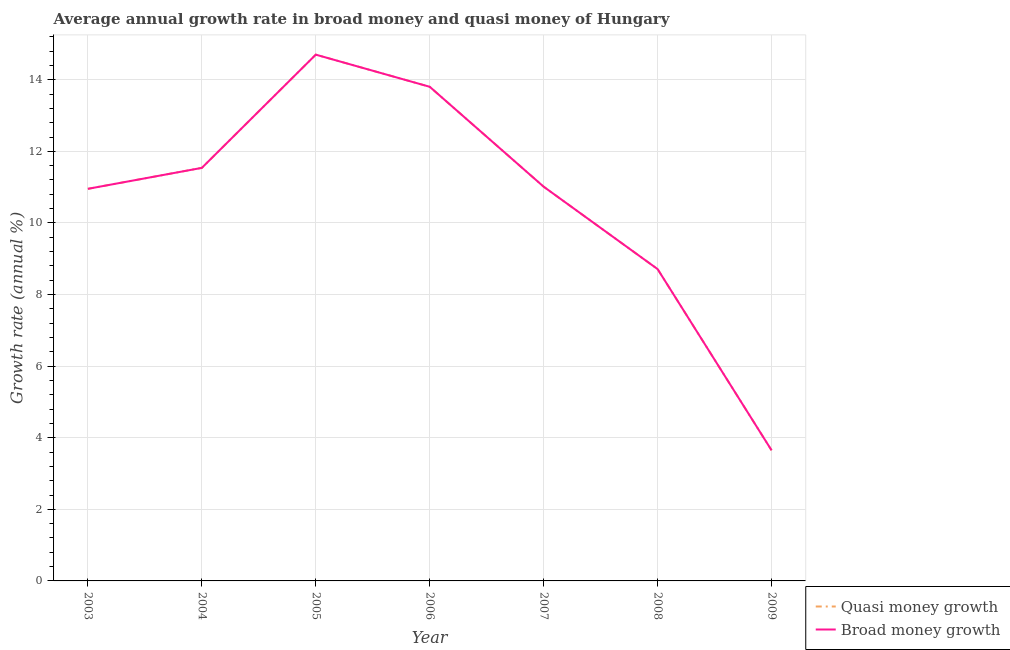Is the number of lines equal to the number of legend labels?
Ensure brevity in your answer.  Yes. What is the annual growth rate in broad money in 2003?
Provide a succinct answer. 10.95. Across all years, what is the maximum annual growth rate in quasi money?
Offer a terse response. 14.7. Across all years, what is the minimum annual growth rate in quasi money?
Your response must be concise. 3.65. In which year was the annual growth rate in quasi money minimum?
Your response must be concise. 2009. What is the total annual growth rate in broad money in the graph?
Your answer should be compact. 74.36. What is the difference between the annual growth rate in broad money in 2006 and that in 2008?
Offer a terse response. 5.09. What is the difference between the annual growth rate in quasi money in 2003 and the annual growth rate in broad money in 2008?
Your answer should be compact. 2.24. What is the average annual growth rate in broad money per year?
Keep it short and to the point. 10.62. What is the ratio of the annual growth rate in quasi money in 2003 to that in 2007?
Provide a short and direct response. 0.99. What is the difference between the highest and the second highest annual growth rate in broad money?
Provide a short and direct response. 0.9. What is the difference between the highest and the lowest annual growth rate in broad money?
Your answer should be very brief. 11.05. In how many years, is the annual growth rate in quasi money greater than the average annual growth rate in quasi money taken over all years?
Give a very brief answer. 5. Is the sum of the annual growth rate in quasi money in 2003 and 2007 greater than the maximum annual growth rate in broad money across all years?
Ensure brevity in your answer.  Yes. Does the annual growth rate in broad money monotonically increase over the years?
Provide a succinct answer. No. Is the annual growth rate in quasi money strictly less than the annual growth rate in broad money over the years?
Make the answer very short. No. How many lines are there?
Your answer should be very brief. 2. Are the values on the major ticks of Y-axis written in scientific E-notation?
Make the answer very short. No. How many legend labels are there?
Ensure brevity in your answer.  2. What is the title of the graph?
Give a very brief answer. Average annual growth rate in broad money and quasi money of Hungary. What is the label or title of the Y-axis?
Give a very brief answer. Growth rate (annual %). What is the Growth rate (annual %) of Quasi money growth in 2003?
Give a very brief answer. 10.95. What is the Growth rate (annual %) in Broad money growth in 2003?
Your answer should be compact. 10.95. What is the Growth rate (annual %) of Quasi money growth in 2004?
Your response must be concise. 11.54. What is the Growth rate (annual %) of Broad money growth in 2004?
Offer a terse response. 11.54. What is the Growth rate (annual %) in Quasi money growth in 2005?
Make the answer very short. 14.7. What is the Growth rate (annual %) of Broad money growth in 2005?
Give a very brief answer. 14.7. What is the Growth rate (annual %) in Quasi money growth in 2006?
Your answer should be compact. 13.8. What is the Growth rate (annual %) of Broad money growth in 2006?
Make the answer very short. 13.8. What is the Growth rate (annual %) in Quasi money growth in 2007?
Your answer should be compact. 11.01. What is the Growth rate (annual %) in Broad money growth in 2007?
Your answer should be very brief. 11.01. What is the Growth rate (annual %) in Quasi money growth in 2008?
Give a very brief answer. 8.71. What is the Growth rate (annual %) in Broad money growth in 2008?
Give a very brief answer. 8.71. What is the Growth rate (annual %) of Quasi money growth in 2009?
Offer a very short reply. 3.65. What is the Growth rate (annual %) of Broad money growth in 2009?
Make the answer very short. 3.65. Across all years, what is the maximum Growth rate (annual %) in Quasi money growth?
Keep it short and to the point. 14.7. Across all years, what is the maximum Growth rate (annual %) in Broad money growth?
Make the answer very short. 14.7. Across all years, what is the minimum Growth rate (annual %) in Quasi money growth?
Offer a very short reply. 3.65. Across all years, what is the minimum Growth rate (annual %) in Broad money growth?
Make the answer very short. 3.65. What is the total Growth rate (annual %) in Quasi money growth in the graph?
Give a very brief answer. 74.36. What is the total Growth rate (annual %) in Broad money growth in the graph?
Your answer should be compact. 74.36. What is the difference between the Growth rate (annual %) in Quasi money growth in 2003 and that in 2004?
Your answer should be compact. -0.59. What is the difference between the Growth rate (annual %) of Broad money growth in 2003 and that in 2004?
Your response must be concise. -0.59. What is the difference between the Growth rate (annual %) of Quasi money growth in 2003 and that in 2005?
Provide a succinct answer. -3.75. What is the difference between the Growth rate (annual %) in Broad money growth in 2003 and that in 2005?
Your answer should be very brief. -3.75. What is the difference between the Growth rate (annual %) of Quasi money growth in 2003 and that in 2006?
Make the answer very short. -2.85. What is the difference between the Growth rate (annual %) in Broad money growth in 2003 and that in 2006?
Provide a succinct answer. -2.85. What is the difference between the Growth rate (annual %) in Quasi money growth in 2003 and that in 2007?
Your answer should be compact. -0.06. What is the difference between the Growth rate (annual %) in Broad money growth in 2003 and that in 2007?
Keep it short and to the point. -0.06. What is the difference between the Growth rate (annual %) in Quasi money growth in 2003 and that in 2008?
Provide a short and direct response. 2.24. What is the difference between the Growth rate (annual %) of Broad money growth in 2003 and that in 2008?
Offer a very short reply. 2.24. What is the difference between the Growth rate (annual %) of Quasi money growth in 2003 and that in 2009?
Give a very brief answer. 7.3. What is the difference between the Growth rate (annual %) of Broad money growth in 2003 and that in 2009?
Provide a succinct answer. 7.3. What is the difference between the Growth rate (annual %) of Quasi money growth in 2004 and that in 2005?
Your answer should be compact. -3.16. What is the difference between the Growth rate (annual %) of Broad money growth in 2004 and that in 2005?
Offer a terse response. -3.16. What is the difference between the Growth rate (annual %) of Quasi money growth in 2004 and that in 2006?
Your response must be concise. -2.27. What is the difference between the Growth rate (annual %) of Broad money growth in 2004 and that in 2006?
Provide a succinct answer. -2.27. What is the difference between the Growth rate (annual %) in Quasi money growth in 2004 and that in 2007?
Provide a succinct answer. 0.53. What is the difference between the Growth rate (annual %) in Broad money growth in 2004 and that in 2007?
Keep it short and to the point. 0.53. What is the difference between the Growth rate (annual %) of Quasi money growth in 2004 and that in 2008?
Your response must be concise. 2.83. What is the difference between the Growth rate (annual %) of Broad money growth in 2004 and that in 2008?
Provide a succinct answer. 2.83. What is the difference between the Growth rate (annual %) of Quasi money growth in 2004 and that in 2009?
Your response must be concise. 7.89. What is the difference between the Growth rate (annual %) of Broad money growth in 2004 and that in 2009?
Keep it short and to the point. 7.89. What is the difference between the Growth rate (annual %) of Quasi money growth in 2005 and that in 2006?
Give a very brief answer. 0.9. What is the difference between the Growth rate (annual %) of Broad money growth in 2005 and that in 2006?
Give a very brief answer. 0.9. What is the difference between the Growth rate (annual %) of Quasi money growth in 2005 and that in 2007?
Offer a terse response. 3.69. What is the difference between the Growth rate (annual %) of Broad money growth in 2005 and that in 2007?
Offer a very short reply. 3.69. What is the difference between the Growth rate (annual %) in Quasi money growth in 2005 and that in 2008?
Keep it short and to the point. 5.99. What is the difference between the Growth rate (annual %) of Broad money growth in 2005 and that in 2008?
Provide a short and direct response. 5.99. What is the difference between the Growth rate (annual %) in Quasi money growth in 2005 and that in 2009?
Ensure brevity in your answer.  11.05. What is the difference between the Growth rate (annual %) in Broad money growth in 2005 and that in 2009?
Provide a short and direct response. 11.05. What is the difference between the Growth rate (annual %) of Quasi money growth in 2006 and that in 2007?
Provide a short and direct response. 2.79. What is the difference between the Growth rate (annual %) of Broad money growth in 2006 and that in 2007?
Your answer should be very brief. 2.79. What is the difference between the Growth rate (annual %) in Quasi money growth in 2006 and that in 2008?
Give a very brief answer. 5.09. What is the difference between the Growth rate (annual %) of Broad money growth in 2006 and that in 2008?
Your response must be concise. 5.09. What is the difference between the Growth rate (annual %) in Quasi money growth in 2006 and that in 2009?
Ensure brevity in your answer.  10.15. What is the difference between the Growth rate (annual %) of Broad money growth in 2006 and that in 2009?
Ensure brevity in your answer.  10.15. What is the difference between the Growth rate (annual %) in Quasi money growth in 2007 and that in 2008?
Offer a very short reply. 2.3. What is the difference between the Growth rate (annual %) in Broad money growth in 2007 and that in 2008?
Keep it short and to the point. 2.3. What is the difference between the Growth rate (annual %) in Quasi money growth in 2007 and that in 2009?
Your answer should be very brief. 7.36. What is the difference between the Growth rate (annual %) of Broad money growth in 2007 and that in 2009?
Your response must be concise. 7.36. What is the difference between the Growth rate (annual %) of Quasi money growth in 2008 and that in 2009?
Your answer should be very brief. 5.06. What is the difference between the Growth rate (annual %) of Broad money growth in 2008 and that in 2009?
Your answer should be compact. 5.06. What is the difference between the Growth rate (annual %) of Quasi money growth in 2003 and the Growth rate (annual %) of Broad money growth in 2004?
Your answer should be very brief. -0.59. What is the difference between the Growth rate (annual %) in Quasi money growth in 2003 and the Growth rate (annual %) in Broad money growth in 2005?
Offer a very short reply. -3.75. What is the difference between the Growth rate (annual %) of Quasi money growth in 2003 and the Growth rate (annual %) of Broad money growth in 2006?
Your answer should be very brief. -2.85. What is the difference between the Growth rate (annual %) of Quasi money growth in 2003 and the Growth rate (annual %) of Broad money growth in 2007?
Offer a terse response. -0.06. What is the difference between the Growth rate (annual %) of Quasi money growth in 2003 and the Growth rate (annual %) of Broad money growth in 2008?
Ensure brevity in your answer.  2.24. What is the difference between the Growth rate (annual %) in Quasi money growth in 2003 and the Growth rate (annual %) in Broad money growth in 2009?
Offer a terse response. 7.3. What is the difference between the Growth rate (annual %) of Quasi money growth in 2004 and the Growth rate (annual %) of Broad money growth in 2005?
Provide a short and direct response. -3.16. What is the difference between the Growth rate (annual %) of Quasi money growth in 2004 and the Growth rate (annual %) of Broad money growth in 2006?
Keep it short and to the point. -2.27. What is the difference between the Growth rate (annual %) of Quasi money growth in 2004 and the Growth rate (annual %) of Broad money growth in 2007?
Make the answer very short. 0.53. What is the difference between the Growth rate (annual %) of Quasi money growth in 2004 and the Growth rate (annual %) of Broad money growth in 2008?
Your answer should be compact. 2.83. What is the difference between the Growth rate (annual %) of Quasi money growth in 2004 and the Growth rate (annual %) of Broad money growth in 2009?
Provide a short and direct response. 7.89. What is the difference between the Growth rate (annual %) in Quasi money growth in 2005 and the Growth rate (annual %) in Broad money growth in 2006?
Ensure brevity in your answer.  0.9. What is the difference between the Growth rate (annual %) of Quasi money growth in 2005 and the Growth rate (annual %) of Broad money growth in 2007?
Keep it short and to the point. 3.69. What is the difference between the Growth rate (annual %) in Quasi money growth in 2005 and the Growth rate (annual %) in Broad money growth in 2008?
Offer a terse response. 5.99. What is the difference between the Growth rate (annual %) of Quasi money growth in 2005 and the Growth rate (annual %) of Broad money growth in 2009?
Your response must be concise. 11.05. What is the difference between the Growth rate (annual %) of Quasi money growth in 2006 and the Growth rate (annual %) of Broad money growth in 2007?
Ensure brevity in your answer.  2.79. What is the difference between the Growth rate (annual %) of Quasi money growth in 2006 and the Growth rate (annual %) of Broad money growth in 2008?
Ensure brevity in your answer.  5.09. What is the difference between the Growth rate (annual %) of Quasi money growth in 2006 and the Growth rate (annual %) of Broad money growth in 2009?
Give a very brief answer. 10.15. What is the difference between the Growth rate (annual %) of Quasi money growth in 2007 and the Growth rate (annual %) of Broad money growth in 2008?
Give a very brief answer. 2.3. What is the difference between the Growth rate (annual %) in Quasi money growth in 2007 and the Growth rate (annual %) in Broad money growth in 2009?
Provide a succinct answer. 7.36. What is the difference between the Growth rate (annual %) in Quasi money growth in 2008 and the Growth rate (annual %) in Broad money growth in 2009?
Keep it short and to the point. 5.06. What is the average Growth rate (annual %) of Quasi money growth per year?
Provide a succinct answer. 10.62. What is the average Growth rate (annual %) of Broad money growth per year?
Give a very brief answer. 10.62. In the year 2003, what is the difference between the Growth rate (annual %) in Quasi money growth and Growth rate (annual %) in Broad money growth?
Keep it short and to the point. 0. In the year 2004, what is the difference between the Growth rate (annual %) of Quasi money growth and Growth rate (annual %) of Broad money growth?
Give a very brief answer. 0. In the year 2008, what is the difference between the Growth rate (annual %) of Quasi money growth and Growth rate (annual %) of Broad money growth?
Provide a short and direct response. 0. What is the ratio of the Growth rate (annual %) in Quasi money growth in 2003 to that in 2004?
Your answer should be compact. 0.95. What is the ratio of the Growth rate (annual %) of Broad money growth in 2003 to that in 2004?
Your response must be concise. 0.95. What is the ratio of the Growth rate (annual %) of Quasi money growth in 2003 to that in 2005?
Provide a short and direct response. 0.74. What is the ratio of the Growth rate (annual %) of Broad money growth in 2003 to that in 2005?
Your answer should be compact. 0.74. What is the ratio of the Growth rate (annual %) of Quasi money growth in 2003 to that in 2006?
Provide a succinct answer. 0.79. What is the ratio of the Growth rate (annual %) in Broad money growth in 2003 to that in 2006?
Offer a terse response. 0.79. What is the ratio of the Growth rate (annual %) of Quasi money growth in 2003 to that in 2007?
Provide a succinct answer. 0.99. What is the ratio of the Growth rate (annual %) in Quasi money growth in 2003 to that in 2008?
Provide a succinct answer. 1.26. What is the ratio of the Growth rate (annual %) of Broad money growth in 2003 to that in 2008?
Make the answer very short. 1.26. What is the ratio of the Growth rate (annual %) of Quasi money growth in 2003 to that in 2009?
Offer a very short reply. 3. What is the ratio of the Growth rate (annual %) of Broad money growth in 2003 to that in 2009?
Your answer should be compact. 3. What is the ratio of the Growth rate (annual %) of Quasi money growth in 2004 to that in 2005?
Your response must be concise. 0.78. What is the ratio of the Growth rate (annual %) of Broad money growth in 2004 to that in 2005?
Offer a very short reply. 0.78. What is the ratio of the Growth rate (annual %) in Quasi money growth in 2004 to that in 2006?
Your response must be concise. 0.84. What is the ratio of the Growth rate (annual %) of Broad money growth in 2004 to that in 2006?
Make the answer very short. 0.84. What is the ratio of the Growth rate (annual %) of Quasi money growth in 2004 to that in 2007?
Offer a terse response. 1.05. What is the ratio of the Growth rate (annual %) in Broad money growth in 2004 to that in 2007?
Give a very brief answer. 1.05. What is the ratio of the Growth rate (annual %) of Quasi money growth in 2004 to that in 2008?
Provide a succinct answer. 1.32. What is the ratio of the Growth rate (annual %) in Broad money growth in 2004 to that in 2008?
Your response must be concise. 1.32. What is the ratio of the Growth rate (annual %) in Quasi money growth in 2004 to that in 2009?
Offer a terse response. 3.16. What is the ratio of the Growth rate (annual %) in Broad money growth in 2004 to that in 2009?
Offer a very short reply. 3.16. What is the ratio of the Growth rate (annual %) in Quasi money growth in 2005 to that in 2006?
Offer a terse response. 1.06. What is the ratio of the Growth rate (annual %) in Broad money growth in 2005 to that in 2006?
Ensure brevity in your answer.  1.06. What is the ratio of the Growth rate (annual %) in Quasi money growth in 2005 to that in 2007?
Keep it short and to the point. 1.33. What is the ratio of the Growth rate (annual %) of Broad money growth in 2005 to that in 2007?
Make the answer very short. 1.33. What is the ratio of the Growth rate (annual %) in Quasi money growth in 2005 to that in 2008?
Ensure brevity in your answer.  1.69. What is the ratio of the Growth rate (annual %) in Broad money growth in 2005 to that in 2008?
Your answer should be compact. 1.69. What is the ratio of the Growth rate (annual %) in Quasi money growth in 2005 to that in 2009?
Your response must be concise. 4.03. What is the ratio of the Growth rate (annual %) of Broad money growth in 2005 to that in 2009?
Offer a very short reply. 4.03. What is the ratio of the Growth rate (annual %) in Quasi money growth in 2006 to that in 2007?
Offer a terse response. 1.25. What is the ratio of the Growth rate (annual %) of Broad money growth in 2006 to that in 2007?
Give a very brief answer. 1.25. What is the ratio of the Growth rate (annual %) in Quasi money growth in 2006 to that in 2008?
Ensure brevity in your answer.  1.58. What is the ratio of the Growth rate (annual %) of Broad money growth in 2006 to that in 2008?
Give a very brief answer. 1.58. What is the ratio of the Growth rate (annual %) of Quasi money growth in 2006 to that in 2009?
Make the answer very short. 3.78. What is the ratio of the Growth rate (annual %) in Broad money growth in 2006 to that in 2009?
Your answer should be very brief. 3.78. What is the ratio of the Growth rate (annual %) in Quasi money growth in 2007 to that in 2008?
Your response must be concise. 1.26. What is the ratio of the Growth rate (annual %) in Broad money growth in 2007 to that in 2008?
Your response must be concise. 1.26. What is the ratio of the Growth rate (annual %) in Quasi money growth in 2007 to that in 2009?
Offer a terse response. 3.02. What is the ratio of the Growth rate (annual %) in Broad money growth in 2007 to that in 2009?
Your answer should be compact. 3.02. What is the ratio of the Growth rate (annual %) in Quasi money growth in 2008 to that in 2009?
Ensure brevity in your answer.  2.39. What is the ratio of the Growth rate (annual %) in Broad money growth in 2008 to that in 2009?
Give a very brief answer. 2.39. What is the difference between the highest and the second highest Growth rate (annual %) in Quasi money growth?
Give a very brief answer. 0.9. What is the difference between the highest and the second highest Growth rate (annual %) of Broad money growth?
Keep it short and to the point. 0.9. What is the difference between the highest and the lowest Growth rate (annual %) of Quasi money growth?
Ensure brevity in your answer.  11.05. What is the difference between the highest and the lowest Growth rate (annual %) of Broad money growth?
Keep it short and to the point. 11.05. 